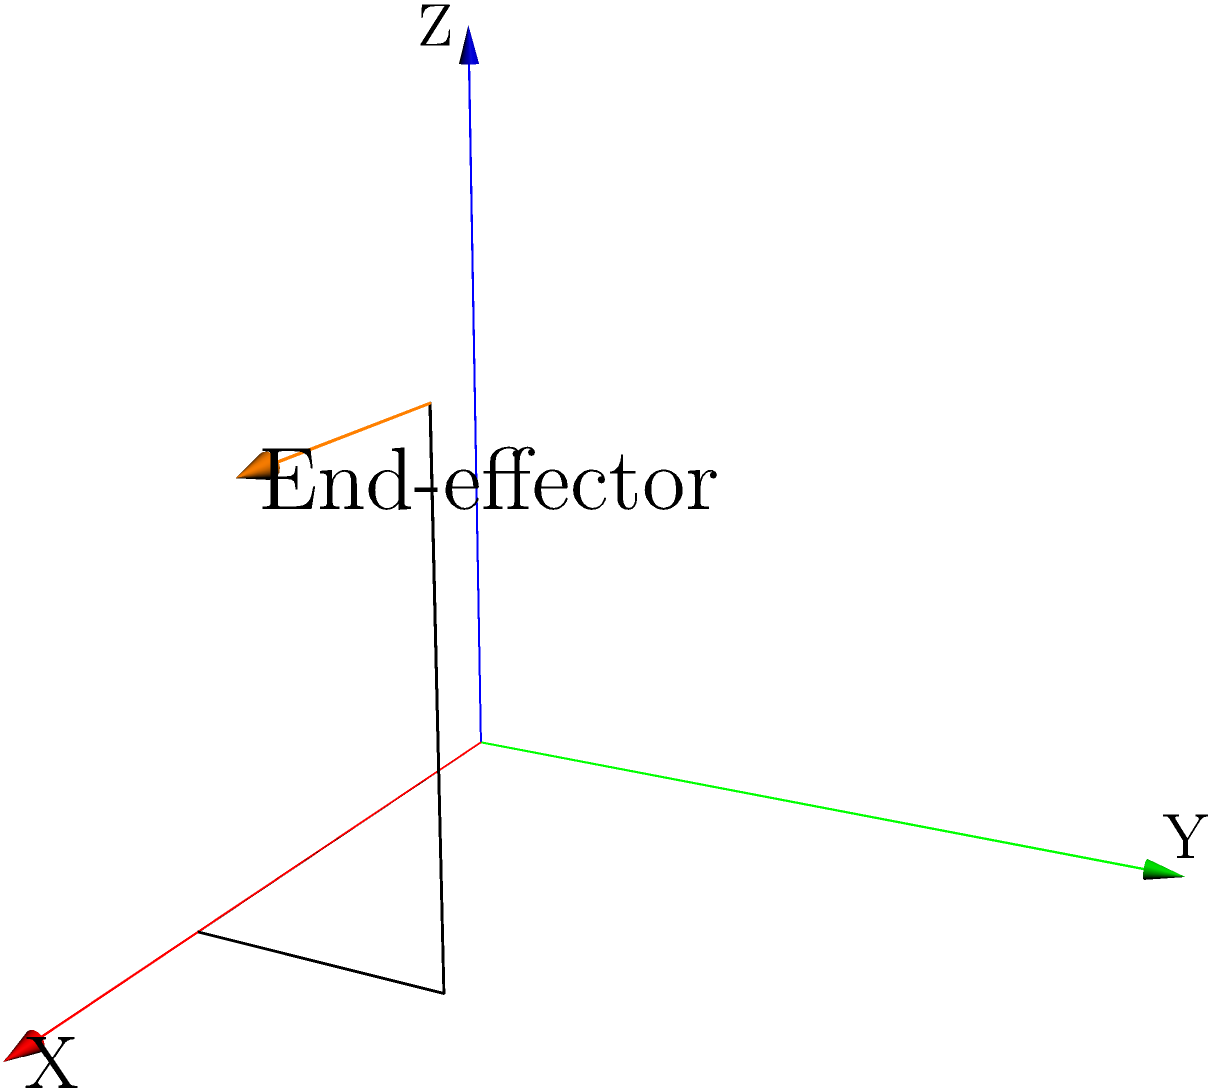Given a robot arm with its end-effector position at $(2,1,2)$ and orientation defined by a rotation of $45^\circ$ around the Z-axis, construct the homogeneous transformation matrix $T$ that represents the end-effector's pose relative to the base frame. How would you express the X-axis unit vector of the end-effector frame in the base frame coordinates? To solve this problem, we'll follow these steps:

1) First, let's construct the homogeneous transformation matrix $T$. It consists of a rotation and a translation:

   $T = \begin{bmatrix} R & t \\ 0 & 1 \end{bmatrix}$

   Where $R$ is the 3x3 rotation matrix and $t$ is the 3x1 translation vector.

2) The rotation is $45^\circ$ around the Z-axis. The rotation matrix for this is:

   $R = \begin{bmatrix} 
   \cos 45^\circ & -\sin 45^\circ & 0 \\
   \sin 45^\circ & \cos 45^\circ & 0 \\
   0 & 0 & 1
   \end{bmatrix} = \begin{bmatrix} 
   \frac{\sqrt{2}}{2} & -\frac{\sqrt{2}}{2} & 0 \\
   \frac{\sqrt{2}}{2} & \frac{\sqrt{2}}{2} & 0 \\
   0 & 0 & 1
   \end{bmatrix}$

3) The translation vector $t$ is simply the position of the end-effector:

   $t = \begin{bmatrix} 2 \\ 1 \\ 2 \end{bmatrix}$

4) Putting this together, we get the homogeneous transformation matrix:

   $T = \begin{bmatrix} 
   \frac{\sqrt{2}}{2} & -\frac{\sqrt{2}}{2} & 0 & 2 \\
   \frac{\sqrt{2}}{2} & \frac{\sqrt{2}}{2} & 0 & 1 \\
   0 & 0 & 1 & 2 \\
   0 & 0 & 0 & 1
   \end{bmatrix}$

5) The X-axis unit vector of the end-effector frame in its local coordinates is always $\begin{bmatrix} 1 \\ 0 \\ 0 \\ 0 \end{bmatrix}$ (note the 0 at the end for homogeneous coordinates).

6) To express this in base frame coordinates, we multiply it by the transformation matrix:

   $T \begin{bmatrix} 1 \\ 0 \\ 0 \\ 0 \end{bmatrix} = \begin{bmatrix} 
   \frac{\sqrt{2}}{2} & -\frac{\sqrt{2}}{2} & 0 & 2 \\
   \frac{\sqrt{2}}{2} & \frac{\sqrt{2}}{2} & 0 & 1 \\
   0 & 0 & 1 & 2 \\
   0 & 0 & 0 & 1
   \end{bmatrix} \begin{bmatrix} 1 \\ 0 \\ 0 \\ 0 \end{bmatrix} = \begin{bmatrix} \frac{\sqrt{2}}{2} \\ \frac{\sqrt{2}}{2} \\ 0 \\ 0 \end{bmatrix}$

Therefore, the X-axis unit vector of the end-effector frame in base frame coordinates is $\begin{bmatrix} \frac{\sqrt{2}}{2} \\ \frac{\sqrt{2}}{2} \\ 0 \end{bmatrix}$.
Answer: $\begin{bmatrix} \frac{\sqrt{2}}{2} \\ \frac{\sqrt{2}}{2} \\ 0 \end{bmatrix}$ 